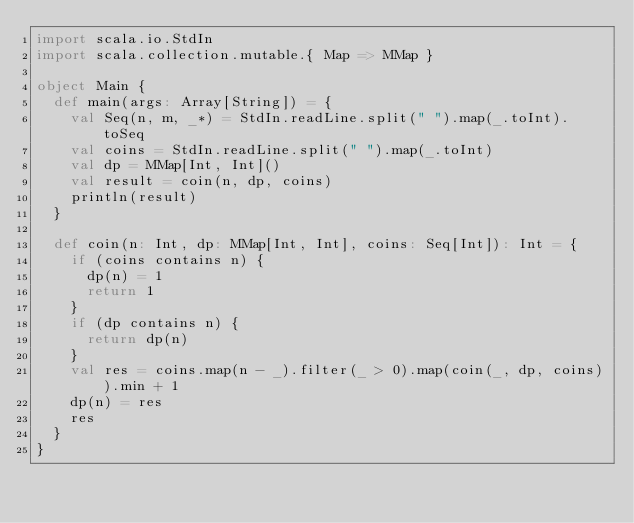<code> <loc_0><loc_0><loc_500><loc_500><_Scala_>import scala.io.StdIn
import scala.collection.mutable.{ Map => MMap }

object Main {
  def main(args: Array[String]) = {
    val Seq(n, m, _*) = StdIn.readLine.split(" ").map(_.toInt).toSeq
    val coins = StdIn.readLine.split(" ").map(_.toInt)
    val dp = MMap[Int, Int]()
    val result = coin(n, dp, coins)
    println(result)
  }

  def coin(n: Int, dp: MMap[Int, Int], coins: Seq[Int]): Int = {
    if (coins contains n) {
      dp(n) = 1
      return 1
    }
    if (dp contains n) {
      return dp(n)
    }
    val res = coins.map(n - _).filter(_ > 0).map(coin(_, dp, coins)).min + 1
    dp(n) = res
    res
  }
}

</code> 